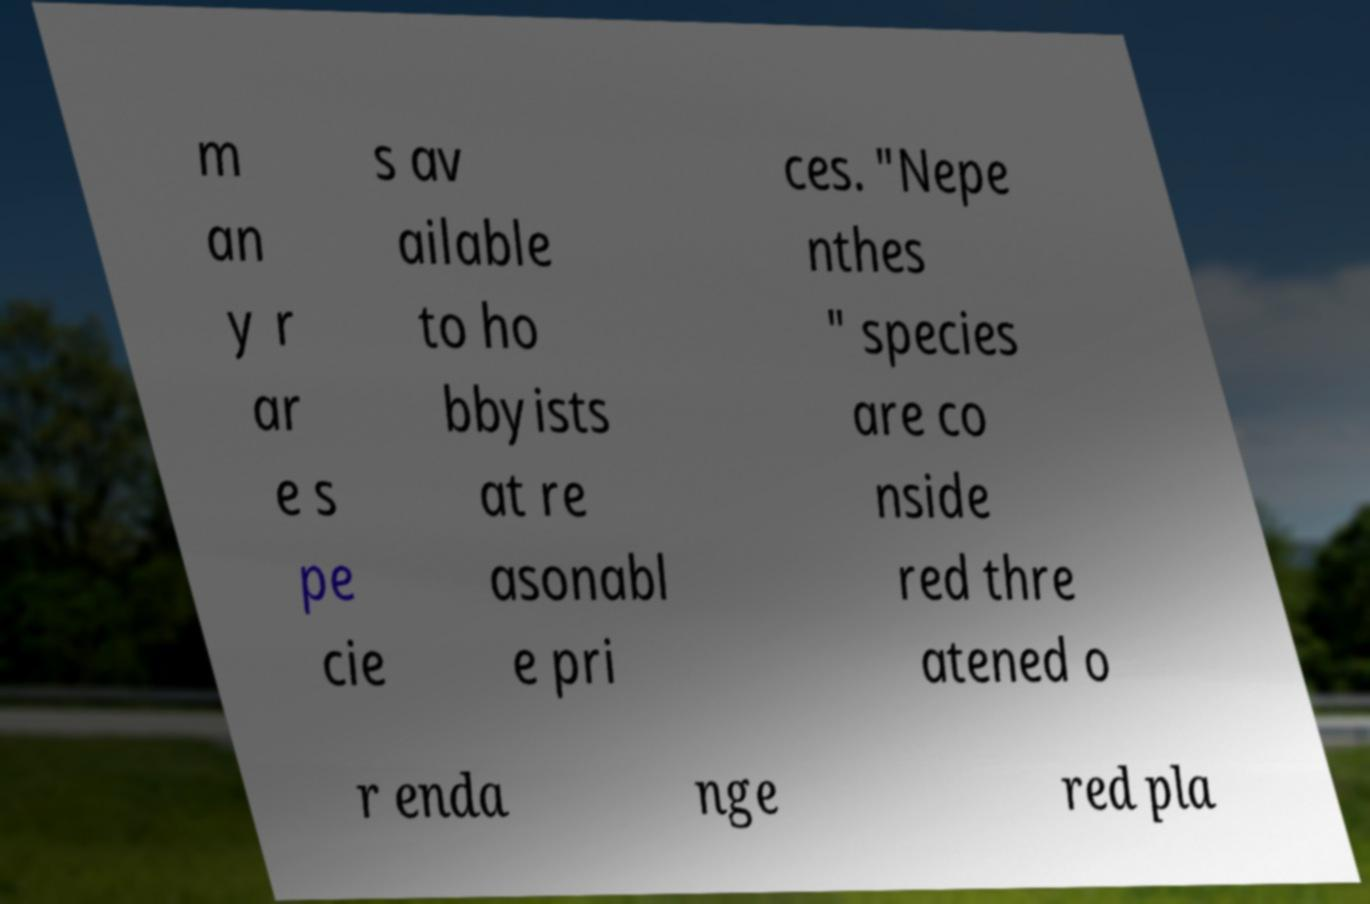Please read and relay the text visible in this image. What does it say? m an y r ar e s pe cie s av ailable to ho bbyists at re asonabl e pri ces. "Nepe nthes " species are co nside red thre atened o r enda nge red pla 